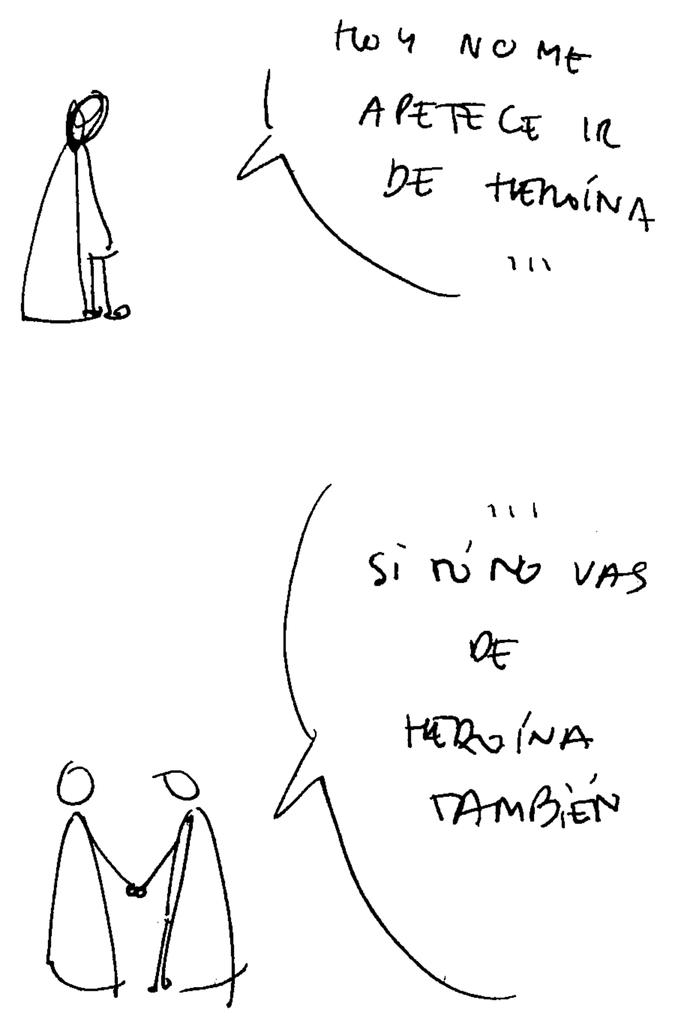What can be seen in the image that represents visual communication? There are drawings in the image. What can be seen in the image that represents written communication? There is written text in the image. What type of pancake is being served in the image? There is no pancake present in the image. What is the source of humor in the image? There is no humor or comedic element present in the image. 